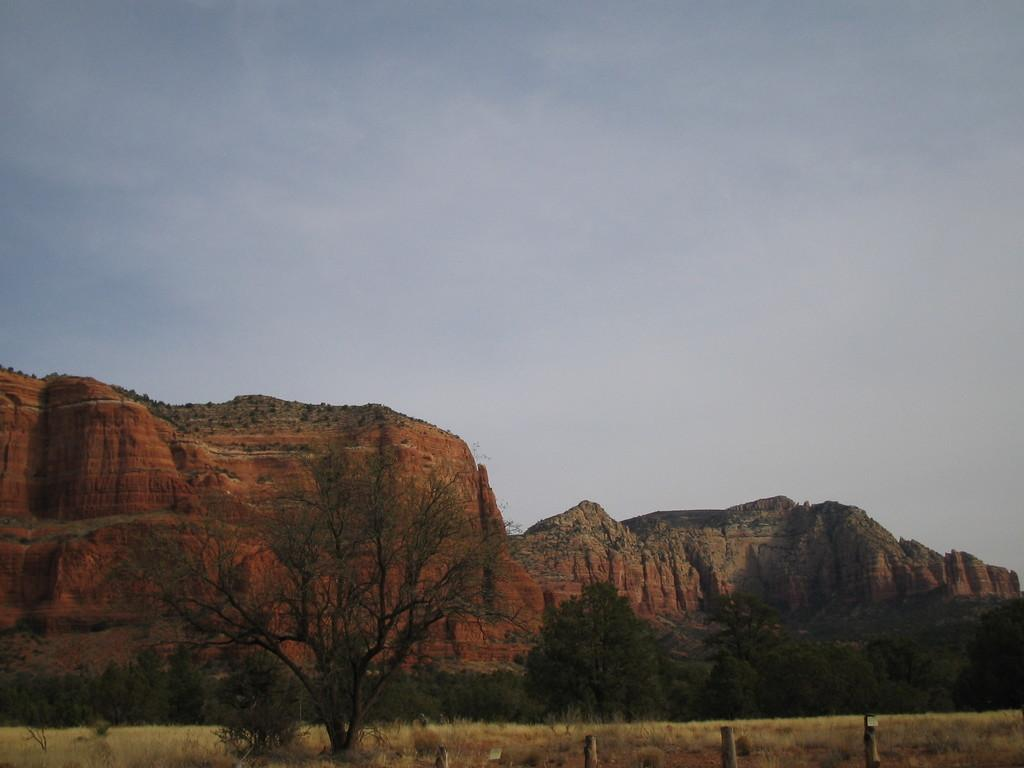What type of setting is depicted in the image? The image is an outside view. What natural elements can be seen in the image? There are trees and hills visible in the image. What is visible at the top of the image? The sky is visible at the top of the image. Can you tell me how many snails are crawling on the trees in the image? There are no snails visible in the image; it only features trees and hills. What type of division is being taught in the image? There is no indication of any teaching or learning activity in the image. 